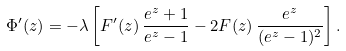<formula> <loc_0><loc_0><loc_500><loc_500>\Phi ^ { \prime } ( z ) = - \lambda \left [ F ^ { \prime } ( z ) \, \frac { e ^ { z } + 1 } { e ^ { z } - 1 } - 2 F ( z ) \, \frac { e ^ { z } } { ( e ^ { z } - 1 ) ^ { 2 } } \right ] .</formula> 